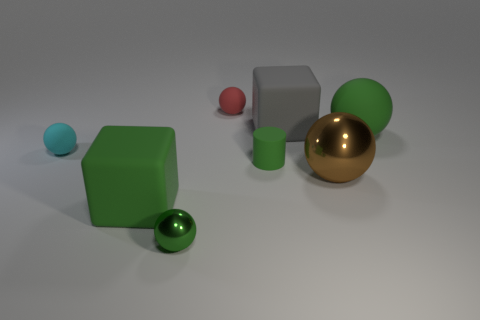Subtract all green matte balls. How many balls are left? 4 Subtract all cyan balls. How many balls are left? 4 Subtract all purple balls. Subtract all cyan cylinders. How many balls are left? 5 Add 2 large gray matte objects. How many objects exist? 10 Subtract all cubes. How many objects are left? 6 Subtract 0 yellow spheres. How many objects are left? 8 Subtract all tiny purple shiny blocks. Subtract all brown balls. How many objects are left? 7 Add 6 big spheres. How many big spheres are left? 8 Add 2 brown objects. How many brown objects exist? 3 